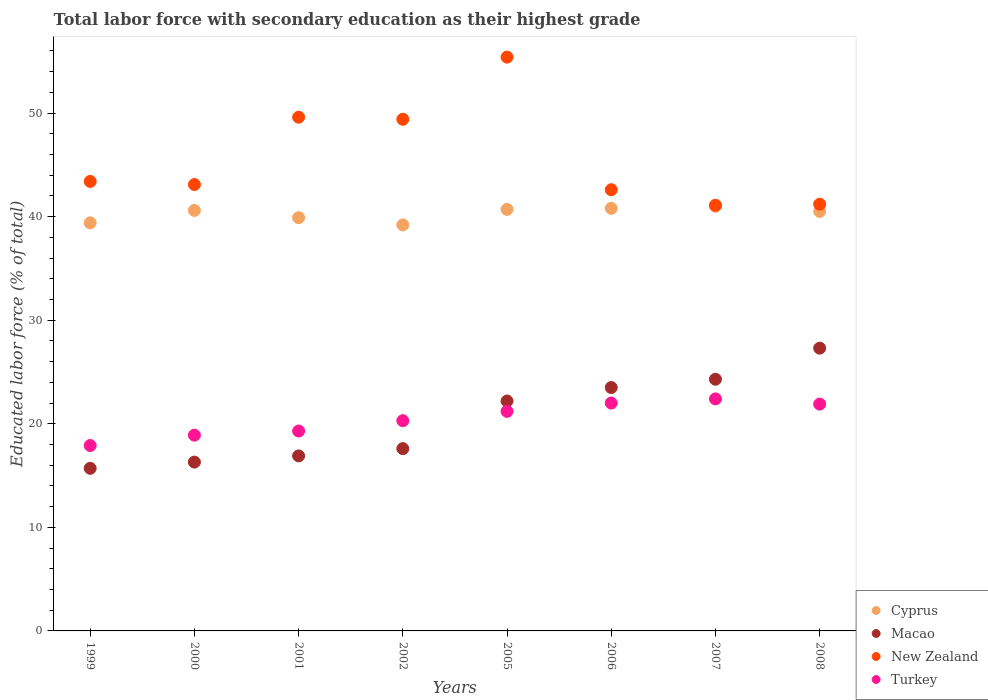How many different coloured dotlines are there?
Your response must be concise. 4. Is the number of dotlines equal to the number of legend labels?
Your answer should be compact. Yes. What is the percentage of total labor force with primary education in Macao in 2005?
Your answer should be very brief. 22.2. Across all years, what is the maximum percentage of total labor force with primary education in Cyprus?
Provide a short and direct response. 41. Across all years, what is the minimum percentage of total labor force with primary education in Macao?
Ensure brevity in your answer.  15.7. What is the total percentage of total labor force with primary education in Turkey in the graph?
Offer a terse response. 163.9. What is the difference between the percentage of total labor force with primary education in Macao in 2002 and that in 2006?
Offer a very short reply. -5.9. What is the difference between the percentage of total labor force with primary education in Turkey in 2006 and the percentage of total labor force with primary education in Cyprus in 1999?
Make the answer very short. -17.4. What is the average percentage of total labor force with primary education in Turkey per year?
Offer a very short reply. 20.49. In the year 2000, what is the difference between the percentage of total labor force with primary education in Macao and percentage of total labor force with primary education in New Zealand?
Offer a very short reply. -26.8. What is the ratio of the percentage of total labor force with primary education in Turkey in 1999 to that in 2002?
Ensure brevity in your answer.  0.88. Is the percentage of total labor force with primary education in Turkey in 2007 less than that in 2008?
Provide a succinct answer. No. What is the difference between the highest and the second highest percentage of total labor force with primary education in Cyprus?
Provide a short and direct response. 0.2. What is the difference between the highest and the lowest percentage of total labor force with primary education in New Zealand?
Provide a succinct answer. 14.3. Does the percentage of total labor force with primary education in Cyprus monotonically increase over the years?
Give a very brief answer. No. Is the percentage of total labor force with primary education in Macao strictly greater than the percentage of total labor force with primary education in Cyprus over the years?
Give a very brief answer. No. Is the percentage of total labor force with primary education in Cyprus strictly less than the percentage of total labor force with primary education in Turkey over the years?
Your answer should be very brief. No. How many dotlines are there?
Provide a short and direct response. 4. What is the difference between two consecutive major ticks on the Y-axis?
Provide a short and direct response. 10. Are the values on the major ticks of Y-axis written in scientific E-notation?
Your answer should be compact. No. Does the graph contain any zero values?
Offer a very short reply. No. Does the graph contain grids?
Keep it short and to the point. No. Where does the legend appear in the graph?
Your response must be concise. Bottom right. How many legend labels are there?
Your answer should be very brief. 4. What is the title of the graph?
Provide a short and direct response. Total labor force with secondary education as their highest grade. What is the label or title of the Y-axis?
Your answer should be very brief. Educated labor force (% of total). What is the Educated labor force (% of total) in Cyprus in 1999?
Give a very brief answer. 39.4. What is the Educated labor force (% of total) of Macao in 1999?
Provide a short and direct response. 15.7. What is the Educated labor force (% of total) of New Zealand in 1999?
Your response must be concise. 43.4. What is the Educated labor force (% of total) of Turkey in 1999?
Provide a succinct answer. 17.9. What is the Educated labor force (% of total) in Cyprus in 2000?
Provide a succinct answer. 40.6. What is the Educated labor force (% of total) of Macao in 2000?
Ensure brevity in your answer.  16.3. What is the Educated labor force (% of total) in New Zealand in 2000?
Provide a succinct answer. 43.1. What is the Educated labor force (% of total) of Turkey in 2000?
Your answer should be very brief. 18.9. What is the Educated labor force (% of total) of Cyprus in 2001?
Your answer should be very brief. 39.9. What is the Educated labor force (% of total) of Macao in 2001?
Your response must be concise. 16.9. What is the Educated labor force (% of total) of New Zealand in 2001?
Your response must be concise. 49.6. What is the Educated labor force (% of total) in Turkey in 2001?
Give a very brief answer. 19.3. What is the Educated labor force (% of total) in Cyprus in 2002?
Provide a succinct answer. 39.2. What is the Educated labor force (% of total) in Macao in 2002?
Offer a very short reply. 17.6. What is the Educated labor force (% of total) in New Zealand in 2002?
Make the answer very short. 49.4. What is the Educated labor force (% of total) in Turkey in 2002?
Provide a short and direct response. 20.3. What is the Educated labor force (% of total) in Cyprus in 2005?
Offer a very short reply. 40.7. What is the Educated labor force (% of total) of Macao in 2005?
Offer a very short reply. 22.2. What is the Educated labor force (% of total) of New Zealand in 2005?
Provide a short and direct response. 55.4. What is the Educated labor force (% of total) in Turkey in 2005?
Keep it short and to the point. 21.2. What is the Educated labor force (% of total) in Cyprus in 2006?
Make the answer very short. 40.8. What is the Educated labor force (% of total) in Macao in 2006?
Offer a terse response. 23.5. What is the Educated labor force (% of total) in New Zealand in 2006?
Offer a very short reply. 42.6. What is the Educated labor force (% of total) of Cyprus in 2007?
Keep it short and to the point. 41. What is the Educated labor force (% of total) in Macao in 2007?
Your answer should be compact. 24.3. What is the Educated labor force (% of total) of New Zealand in 2007?
Provide a succinct answer. 41.1. What is the Educated labor force (% of total) of Turkey in 2007?
Your answer should be very brief. 22.4. What is the Educated labor force (% of total) of Cyprus in 2008?
Give a very brief answer. 40.5. What is the Educated labor force (% of total) in Macao in 2008?
Offer a very short reply. 27.3. What is the Educated labor force (% of total) of New Zealand in 2008?
Give a very brief answer. 41.2. What is the Educated labor force (% of total) of Turkey in 2008?
Give a very brief answer. 21.9. Across all years, what is the maximum Educated labor force (% of total) of Macao?
Keep it short and to the point. 27.3. Across all years, what is the maximum Educated labor force (% of total) of New Zealand?
Give a very brief answer. 55.4. Across all years, what is the maximum Educated labor force (% of total) of Turkey?
Give a very brief answer. 22.4. Across all years, what is the minimum Educated labor force (% of total) in Cyprus?
Provide a succinct answer. 39.2. Across all years, what is the minimum Educated labor force (% of total) of Macao?
Make the answer very short. 15.7. Across all years, what is the minimum Educated labor force (% of total) in New Zealand?
Ensure brevity in your answer.  41.1. Across all years, what is the minimum Educated labor force (% of total) in Turkey?
Make the answer very short. 17.9. What is the total Educated labor force (% of total) in Cyprus in the graph?
Offer a very short reply. 322.1. What is the total Educated labor force (% of total) in Macao in the graph?
Your answer should be very brief. 163.8. What is the total Educated labor force (% of total) in New Zealand in the graph?
Ensure brevity in your answer.  365.8. What is the total Educated labor force (% of total) in Turkey in the graph?
Your answer should be very brief. 163.9. What is the difference between the Educated labor force (% of total) of Cyprus in 1999 and that in 2000?
Provide a short and direct response. -1.2. What is the difference between the Educated labor force (% of total) of Macao in 1999 and that in 2000?
Keep it short and to the point. -0.6. What is the difference between the Educated labor force (% of total) in Turkey in 1999 and that in 2000?
Keep it short and to the point. -1. What is the difference between the Educated labor force (% of total) of Cyprus in 1999 and that in 2001?
Give a very brief answer. -0.5. What is the difference between the Educated labor force (% of total) of Turkey in 1999 and that in 2001?
Give a very brief answer. -1.4. What is the difference between the Educated labor force (% of total) of Cyprus in 1999 and that in 2002?
Provide a short and direct response. 0.2. What is the difference between the Educated labor force (% of total) of Macao in 1999 and that in 2002?
Provide a succinct answer. -1.9. What is the difference between the Educated labor force (% of total) of New Zealand in 1999 and that in 2002?
Offer a terse response. -6. What is the difference between the Educated labor force (% of total) in Macao in 1999 and that in 2005?
Your answer should be very brief. -6.5. What is the difference between the Educated labor force (% of total) of New Zealand in 1999 and that in 2005?
Keep it short and to the point. -12. What is the difference between the Educated labor force (% of total) of Turkey in 1999 and that in 2005?
Offer a very short reply. -3.3. What is the difference between the Educated labor force (% of total) of Macao in 1999 and that in 2006?
Provide a short and direct response. -7.8. What is the difference between the Educated labor force (% of total) of Turkey in 1999 and that in 2006?
Provide a succinct answer. -4.1. What is the difference between the Educated labor force (% of total) in Macao in 1999 and that in 2007?
Your answer should be very brief. -8.6. What is the difference between the Educated labor force (% of total) of Cyprus in 1999 and that in 2008?
Make the answer very short. -1.1. What is the difference between the Educated labor force (% of total) of Macao in 1999 and that in 2008?
Provide a succinct answer. -11.6. What is the difference between the Educated labor force (% of total) in Turkey in 1999 and that in 2008?
Make the answer very short. -4. What is the difference between the Educated labor force (% of total) in Cyprus in 2000 and that in 2001?
Ensure brevity in your answer.  0.7. What is the difference between the Educated labor force (% of total) in Macao in 2000 and that in 2001?
Offer a very short reply. -0.6. What is the difference between the Educated labor force (% of total) in New Zealand in 2000 and that in 2001?
Provide a short and direct response. -6.5. What is the difference between the Educated labor force (% of total) in Cyprus in 2000 and that in 2002?
Offer a very short reply. 1.4. What is the difference between the Educated labor force (% of total) of Turkey in 2000 and that in 2002?
Ensure brevity in your answer.  -1.4. What is the difference between the Educated labor force (% of total) in Cyprus in 2000 and that in 2005?
Ensure brevity in your answer.  -0.1. What is the difference between the Educated labor force (% of total) of Macao in 2000 and that in 2006?
Your answer should be compact. -7.2. What is the difference between the Educated labor force (% of total) of Cyprus in 2000 and that in 2007?
Keep it short and to the point. -0.4. What is the difference between the Educated labor force (% of total) of New Zealand in 2000 and that in 2007?
Your response must be concise. 2. What is the difference between the Educated labor force (% of total) of Cyprus in 2000 and that in 2008?
Ensure brevity in your answer.  0.1. What is the difference between the Educated labor force (% of total) in New Zealand in 2000 and that in 2008?
Your answer should be compact. 1.9. What is the difference between the Educated labor force (% of total) in Macao in 2001 and that in 2002?
Offer a terse response. -0.7. What is the difference between the Educated labor force (% of total) in New Zealand in 2001 and that in 2002?
Your answer should be compact. 0.2. What is the difference between the Educated labor force (% of total) in Turkey in 2001 and that in 2002?
Your answer should be compact. -1. What is the difference between the Educated labor force (% of total) of Macao in 2001 and that in 2005?
Make the answer very short. -5.3. What is the difference between the Educated labor force (% of total) of New Zealand in 2001 and that in 2005?
Your answer should be compact. -5.8. What is the difference between the Educated labor force (% of total) in Macao in 2001 and that in 2007?
Keep it short and to the point. -7.4. What is the difference between the Educated labor force (% of total) in Cyprus in 2001 and that in 2008?
Keep it short and to the point. -0.6. What is the difference between the Educated labor force (% of total) in New Zealand in 2001 and that in 2008?
Your response must be concise. 8.4. What is the difference between the Educated labor force (% of total) of Turkey in 2001 and that in 2008?
Your answer should be compact. -2.6. What is the difference between the Educated labor force (% of total) of Cyprus in 2002 and that in 2005?
Provide a succinct answer. -1.5. What is the difference between the Educated labor force (% of total) of Macao in 2002 and that in 2005?
Offer a very short reply. -4.6. What is the difference between the Educated labor force (% of total) of Turkey in 2002 and that in 2005?
Provide a short and direct response. -0.9. What is the difference between the Educated labor force (% of total) in New Zealand in 2002 and that in 2006?
Give a very brief answer. 6.8. What is the difference between the Educated labor force (% of total) in Turkey in 2002 and that in 2006?
Give a very brief answer. -1.7. What is the difference between the Educated labor force (% of total) in Cyprus in 2002 and that in 2007?
Offer a terse response. -1.8. What is the difference between the Educated labor force (% of total) of New Zealand in 2002 and that in 2007?
Make the answer very short. 8.3. What is the difference between the Educated labor force (% of total) of Turkey in 2002 and that in 2007?
Keep it short and to the point. -2.1. What is the difference between the Educated labor force (% of total) in New Zealand in 2002 and that in 2008?
Keep it short and to the point. 8.2. What is the difference between the Educated labor force (% of total) in Cyprus in 2005 and that in 2006?
Give a very brief answer. -0.1. What is the difference between the Educated labor force (% of total) of Macao in 2005 and that in 2007?
Keep it short and to the point. -2.1. What is the difference between the Educated labor force (% of total) in New Zealand in 2005 and that in 2007?
Provide a succinct answer. 14.3. What is the difference between the Educated labor force (% of total) of Cyprus in 2005 and that in 2008?
Your answer should be compact. 0.2. What is the difference between the Educated labor force (% of total) of Macao in 2005 and that in 2008?
Keep it short and to the point. -5.1. What is the difference between the Educated labor force (% of total) in Cyprus in 2006 and that in 2007?
Your answer should be very brief. -0.2. What is the difference between the Educated labor force (% of total) of Turkey in 2006 and that in 2007?
Make the answer very short. -0.4. What is the difference between the Educated labor force (% of total) in Cyprus in 2006 and that in 2008?
Keep it short and to the point. 0.3. What is the difference between the Educated labor force (% of total) of Macao in 2006 and that in 2008?
Ensure brevity in your answer.  -3.8. What is the difference between the Educated labor force (% of total) in New Zealand in 2006 and that in 2008?
Offer a terse response. 1.4. What is the difference between the Educated labor force (% of total) of Cyprus in 2007 and that in 2008?
Offer a terse response. 0.5. What is the difference between the Educated labor force (% of total) of Cyprus in 1999 and the Educated labor force (% of total) of Macao in 2000?
Offer a very short reply. 23.1. What is the difference between the Educated labor force (% of total) in Cyprus in 1999 and the Educated labor force (% of total) in Turkey in 2000?
Keep it short and to the point. 20.5. What is the difference between the Educated labor force (% of total) of Macao in 1999 and the Educated labor force (% of total) of New Zealand in 2000?
Offer a terse response. -27.4. What is the difference between the Educated labor force (% of total) in Cyprus in 1999 and the Educated labor force (% of total) in Macao in 2001?
Offer a terse response. 22.5. What is the difference between the Educated labor force (% of total) in Cyprus in 1999 and the Educated labor force (% of total) in Turkey in 2001?
Your answer should be very brief. 20.1. What is the difference between the Educated labor force (% of total) of Macao in 1999 and the Educated labor force (% of total) of New Zealand in 2001?
Provide a succinct answer. -33.9. What is the difference between the Educated labor force (% of total) of New Zealand in 1999 and the Educated labor force (% of total) of Turkey in 2001?
Your response must be concise. 24.1. What is the difference between the Educated labor force (% of total) in Cyprus in 1999 and the Educated labor force (% of total) in Macao in 2002?
Make the answer very short. 21.8. What is the difference between the Educated labor force (% of total) of Macao in 1999 and the Educated labor force (% of total) of New Zealand in 2002?
Offer a terse response. -33.7. What is the difference between the Educated labor force (% of total) of Macao in 1999 and the Educated labor force (% of total) of Turkey in 2002?
Ensure brevity in your answer.  -4.6. What is the difference between the Educated labor force (% of total) of New Zealand in 1999 and the Educated labor force (% of total) of Turkey in 2002?
Keep it short and to the point. 23.1. What is the difference between the Educated labor force (% of total) in Cyprus in 1999 and the Educated labor force (% of total) in Macao in 2005?
Your answer should be compact. 17.2. What is the difference between the Educated labor force (% of total) in Cyprus in 1999 and the Educated labor force (% of total) in New Zealand in 2005?
Your answer should be very brief. -16. What is the difference between the Educated labor force (% of total) of Macao in 1999 and the Educated labor force (% of total) of New Zealand in 2005?
Your response must be concise. -39.7. What is the difference between the Educated labor force (% of total) of Cyprus in 1999 and the Educated labor force (% of total) of Macao in 2006?
Make the answer very short. 15.9. What is the difference between the Educated labor force (% of total) of Cyprus in 1999 and the Educated labor force (% of total) of New Zealand in 2006?
Your answer should be compact. -3.2. What is the difference between the Educated labor force (% of total) in Cyprus in 1999 and the Educated labor force (% of total) in Turkey in 2006?
Make the answer very short. 17.4. What is the difference between the Educated labor force (% of total) of Macao in 1999 and the Educated labor force (% of total) of New Zealand in 2006?
Offer a terse response. -26.9. What is the difference between the Educated labor force (% of total) of New Zealand in 1999 and the Educated labor force (% of total) of Turkey in 2006?
Offer a very short reply. 21.4. What is the difference between the Educated labor force (% of total) of Cyprus in 1999 and the Educated labor force (% of total) of Macao in 2007?
Give a very brief answer. 15.1. What is the difference between the Educated labor force (% of total) in Cyprus in 1999 and the Educated labor force (% of total) in Turkey in 2007?
Your response must be concise. 17. What is the difference between the Educated labor force (% of total) in Macao in 1999 and the Educated labor force (% of total) in New Zealand in 2007?
Your response must be concise. -25.4. What is the difference between the Educated labor force (% of total) in New Zealand in 1999 and the Educated labor force (% of total) in Turkey in 2007?
Your answer should be very brief. 21. What is the difference between the Educated labor force (% of total) in Cyprus in 1999 and the Educated labor force (% of total) in Macao in 2008?
Ensure brevity in your answer.  12.1. What is the difference between the Educated labor force (% of total) in Cyprus in 1999 and the Educated labor force (% of total) in Turkey in 2008?
Provide a succinct answer. 17.5. What is the difference between the Educated labor force (% of total) of Macao in 1999 and the Educated labor force (% of total) of New Zealand in 2008?
Your answer should be very brief. -25.5. What is the difference between the Educated labor force (% of total) in New Zealand in 1999 and the Educated labor force (% of total) in Turkey in 2008?
Your answer should be very brief. 21.5. What is the difference between the Educated labor force (% of total) in Cyprus in 2000 and the Educated labor force (% of total) in Macao in 2001?
Keep it short and to the point. 23.7. What is the difference between the Educated labor force (% of total) of Cyprus in 2000 and the Educated labor force (% of total) of New Zealand in 2001?
Your answer should be very brief. -9. What is the difference between the Educated labor force (% of total) in Cyprus in 2000 and the Educated labor force (% of total) in Turkey in 2001?
Offer a very short reply. 21.3. What is the difference between the Educated labor force (% of total) in Macao in 2000 and the Educated labor force (% of total) in New Zealand in 2001?
Make the answer very short. -33.3. What is the difference between the Educated labor force (% of total) of Macao in 2000 and the Educated labor force (% of total) of Turkey in 2001?
Ensure brevity in your answer.  -3. What is the difference between the Educated labor force (% of total) in New Zealand in 2000 and the Educated labor force (% of total) in Turkey in 2001?
Your response must be concise. 23.8. What is the difference between the Educated labor force (% of total) in Cyprus in 2000 and the Educated labor force (% of total) in Turkey in 2002?
Give a very brief answer. 20.3. What is the difference between the Educated labor force (% of total) of Macao in 2000 and the Educated labor force (% of total) of New Zealand in 2002?
Keep it short and to the point. -33.1. What is the difference between the Educated labor force (% of total) of New Zealand in 2000 and the Educated labor force (% of total) of Turkey in 2002?
Your response must be concise. 22.8. What is the difference between the Educated labor force (% of total) of Cyprus in 2000 and the Educated labor force (% of total) of Macao in 2005?
Your response must be concise. 18.4. What is the difference between the Educated labor force (% of total) of Cyprus in 2000 and the Educated labor force (% of total) of New Zealand in 2005?
Your answer should be compact. -14.8. What is the difference between the Educated labor force (% of total) in Cyprus in 2000 and the Educated labor force (% of total) in Turkey in 2005?
Provide a succinct answer. 19.4. What is the difference between the Educated labor force (% of total) of Macao in 2000 and the Educated labor force (% of total) of New Zealand in 2005?
Provide a short and direct response. -39.1. What is the difference between the Educated labor force (% of total) of New Zealand in 2000 and the Educated labor force (% of total) of Turkey in 2005?
Provide a short and direct response. 21.9. What is the difference between the Educated labor force (% of total) in Cyprus in 2000 and the Educated labor force (% of total) in New Zealand in 2006?
Keep it short and to the point. -2. What is the difference between the Educated labor force (% of total) of Cyprus in 2000 and the Educated labor force (% of total) of Turkey in 2006?
Keep it short and to the point. 18.6. What is the difference between the Educated labor force (% of total) in Macao in 2000 and the Educated labor force (% of total) in New Zealand in 2006?
Offer a very short reply. -26.3. What is the difference between the Educated labor force (% of total) in New Zealand in 2000 and the Educated labor force (% of total) in Turkey in 2006?
Provide a succinct answer. 21.1. What is the difference between the Educated labor force (% of total) of Cyprus in 2000 and the Educated labor force (% of total) of New Zealand in 2007?
Ensure brevity in your answer.  -0.5. What is the difference between the Educated labor force (% of total) of Cyprus in 2000 and the Educated labor force (% of total) of Turkey in 2007?
Ensure brevity in your answer.  18.2. What is the difference between the Educated labor force (% of total) in Macao in 2000 and the Educated labor force (% of total) in New Zealand in 2007?
Your answer should be very brief. -24.8. What is the difference between the Educated labor force (% of total) in Macao in 2000 and the Educated labor force (% of total) in Turkey in 2007?
Provide a short and direct response. -6.1. What is the difference between the Educated labor force (% of total) of New Zealand in 2000 and the Educated labor force (% of total) of Turkey in 2007?
Your answer should be compact. 20.7. What is the difference between the Educated labor force (% of total) of Cyprus in 2000 and the Educated labor force (% of total) of New Zealand in 2008?
Offer a terse response. -0.6. What is the difference between the Educated labor force (% of total) of Cyprus in 2000 and the Educated labor force (% of total) of Turkey in 2008?
Offer a very short reply. 18.7. What is the difference between the Educated labor force (% of total) in Macao in 2000 and the Educated labor force (% of total) in New Zealand in 2008?
Your answer should be compact. -24.9. What is the difference between the Educated labor force (% of total) of Macao in 2000 and the Educated labor force (% of total) of Turkey in 2008?
Offer a terse response. -5.6. What is the difference between the Educated labor force (% of total) of New Zealand in 2000 and the Educated labor force (% of total) of Turkey in 2008?
Give a very brief answer. 21.2. What is the difference between the Educated labor force (% of total) of Cyprus in 2001 and the Educated labor force (% of total) of Macao in 2002?
Provide a succinct answer. 22.3. What is the difference between the Educated labor force (% of total) of Cyprus in 2001 and the Educated labor force (% of total) of New Zealand in 2002?
Ensure brevity in your answer.  -9.5. What is the difference between the Educated labor force (% of total) in Cyprus in 2001 and the Educated labor force (% of total) in Turkey in 2002?
Offer a very short reply. 19.6. What is the difference between the Educated labor force (% of total) of Macao in 2001 and the Educated labor force (% of total) of New Zealand in 2002?
Your response must be concise. -32.5. What is the difference between the Educated labor force (% of total) of New Zealand in 2001 and the Educated labor force (% of total) of Turkey in 2002?
Keep it short and to the point. 29.3. What is the difference between the Educated labor force (% of total) of Cyprus in 2001 and the Educated labor force (% of total) of Macao in 2005?
Offer a very short reply. 17.7. What is the difference between the Educated labor force (% of total) in Cyprus in 2001 and the Educated labor force (% of total) in New Zealand in 2005?
Your answer should be compact. -15.5. What is the difference between the Educated labor force (% of total) of Macao in 2001 and the Educated labor force (% of total) of New Zealand in 2005?
Your answer should be very brief. -38.5. What is the difference between the Educated labor force (% of total) in Macao in 2001 and the Educated labor force (% of total) in Turkey in 2005?
Provide a short and direct response. -4.3. What is the difference between the Educated labor force (% of total) in New Zealand in 2001 and the Educated labor force (% of total) in Turkey in 2005?
Ensure brevity in your answer.  28.4. What is the difference between the Educated labor force (% of total) of Cyprus in 2001 and the Educated labor force (% of total) of Turkey in 2006?
Offer a terse response. 17.9. What is the difference between the Educated labor force (% of total) of Macao in 2001 and the Educated labor force (% of total) of New Zealand in 2006?
Your answer should be very brief. -25.7. What is the difference between the Educated labor force (% of total) in Macao in 2001 and the Educated labor force (% of total) in Turkey in 2006?
Make the answer very short. -5.1. What is the difference between the Educated labor force (% of total) of New Zealand in 2001 and the Educated labor force (% of total) of Turkey in 2006?
Your answer should be very brief. 27.6. What is the difference between the Educated labor force (% of total) in Cyprus in 2001 and the Educated labor force (% of total) in Macao in 2007?
Give a very brief answer. 15.6. What is the difference between the Educated labor force (% of total) in Cyprus in 2001 and the Educated labor force (% of total) in Turkey in 2007?
Give a very brief answer. 17.5. What is the difference between the Educated labor force (% of total) of Macao in 2001 and the Educated labor force (% of total) of New Zealand in 2007?
Your answer should be compact. -24.2. What is the difference between the Educated labor force (% of total) of New Zealand in 2001 and the Educated labor force (% of total) of Turkey in 2007?
Keep it short and to the point. 27.2. What is the difference between the Educated labor force (% of total) of Cyprus in 2001 and the Educated labor force (% of total) of New Zealand in 2008?
Give a very brief answer. -1.3. What is the difference between the Educated labor force (% of total) of Cyprus in 2001 and the Educated labor force (% of total) of Turkey in 2008?
Provide a succinct answer. 18. What is the difference between the Educated labor force (% of total) of Macao in 2001 and the Educated labor force (% of total) of New Zealand in 2008?
Offer a very short reply. -24.3. What is the difference between the Educated labor force (% of total) of New Zealand in 2001 and the Educated labor force (% of total) of Turkey in 2008?
Offer a very short reply. 27.7. What is the difference between the Educated labor force (% of total) of Cyprus in 2002 and the Educated labor force (% of total) of New Zealand in 2005?
Give a very brief answer. -16.2. What is the difference between the Educated labor force (% of total) of Macao in 2002 and the Educated labor force (% of total) of New Zealand in 2005?
Ensure brevity in your answer.  -37.8. What is the difference between the Educated labor force (% of total) of New Zealand in 2002 and the Educated labor force (% of total) of Turkey in 2005?
Provide a short and direct response. 28.2. What is the difference between the Educated labor force (% of total) in Cyprus in 2002 and the Educated labor force (% of total) in Macao in 2006?
Offer a terse response. 15.7. What is the difference between the Educated labor force (% of total) of Cyprus in 2002 and the Educated labor force (% of total) of New Zealand in 2006?
Keep it short and to the point. -3.4. What is the difference between the Educated labor force (% of total) in Macao in 2002 and the Educated labor force (% of total) in Turkey in 2006?
Your answer should be very brief. -4.4. What is the difference between the Educated labor force (% of total) in New Zealand in 2002 and the Educated labor force (% of total) in Turkey in 2006?
Make the answer very short. 27.4. What is the difference between the Educated labor force (% of total) in Macao in 2002 and the Educated labor force (% of total) in New Zealand in 2007?
Provide a short and direct response. -23.5. What is the difference between the Educated labor force (% of total) in Cyprus in 2002 and the Educated labor force (% of total) in New Zealand in 2008?
Your answer should be very brief. -2. What is the difference between the Educated labor force (% of total) in Cyprus in 2002 and the Educated labor force (% of total) in Turkey in 2008?
Provide a short and direct response. 17.3. What is the difference between the Educated labor force (% of total) in Macao in 2002 and the Educated labor force (% of total) in New Zealand in 2008?
Offer a terse response. -23.6. What is the difference between the Educated labor force (% of total) in Macao in 2002 and the Educated labor force (% of total) in Turkey in 2008?
Provide a succinct answer. -4.3. What is the difference between the Educated labor force (% of total) in Cyprus in 2005 and the Educated labor force (% of total) in New Zealand in 2006?
Provide a short and direct response. -1.9. What is the difference between the Educated labor force (% of total) of Macao in 2005 and the Educated labor force (% of total) of New Zealand in 2006?
Your answer should be compact. -20.4. What is the difference between the Educated labor force (% of total) in Macao in 2005 and the Educated labor force (% of total) in Turkey in 2006?
Your answer should be compact. 0.2. What is the difference between the Educated labor force (% of total) of New Zealand in 2005 and the Educated labor force (% of total) of Turkey in 2006?
Ensure brevity in your answer.  33.4. What is the difference between the Educated labor force (% of total) of Cyprus in 2005 and the Educated labor force (% of total) of Macao in 2007?
Give a very brief answer. 16.4. What is the difference between the Educated labor force (% of total) of Macao in 2005 and the Educated labor force (% of total) of New Zealand in 2007?
Make the answer very short. -18.9. What is the difference between the Educated labor force (% of total) of Macao in 2005 and the Educated labor force (% of total) of Turkey in 2007?
Provide a succinct answer. -0.2. What is the difference between the Educated labor force (% of total) in Cyprus in 2005 and the Educated labor force (% of total) in Macao in 2008?
Offer a terse response. 13.4. What is the difference between the Educated labor force (% of total) in Cyprus in 2005 and the Educated labor force (% of total) in New Zealand in 2008?
Offer a terse response. -0.5. What is the difference between the Educated labor force (% of total) of Macao in 2005 and the Educated labor force (% of total) of New Zealand in 2008?
Offer a terse response. -19. What is the difference between the Educated labor force (% of total) in Macao in 2005 and the Educated labor force (% of total) in Turkey in 2008?
Offer a very short reply. 0.3. What is the difference between the Educated labor force (% of total) of New Zealand in 2005 and the Educated labor force (% of total) of Turkey in 2008?
Your response must be concise. 33.5. What is the difference between the Educated labor force (% of total) of Macao in 2006 and the Educated labor force (% of total) of New Zealand in 2007?
Offer a terse response. -17.6. What is the difference between the Educated labor force (% of total) of New Zealand in 2006 and the Educated labor force (% of total) of Turkey in 2007?
Give a very brief answer. 20.2. What is the difference between the Educated labor force (% of total) in Cyprus in 2006 and the Educated labor force (% of total) in Macao in 2008?
Offer a very short reply. 13.5. What is the difference between the Educated labor force (% of total) of Cyprus in 2006 and the Educated labor force (% of total) of New Zealand in 2008?
Your response must be concise. -0.4. What is the difference between the Educated labor force (% of total) in Cyprus in 2006 and the Educated labor force (% of total) in Turkey in 2008?
Provide a succinct answer. 18.9. What is the difference between the Educated labor force (% of total) in Macao in 2006 and the Educated labor force (% of total) in New Zealand in 2008?
Make the answer very short. -17.7. What is the difference between the Educated labor force (% of total) in Macao in 2006 and the Educated labor force (% of total) in Turkey in 2008?
Offer a very short reply. 1.6. What is the difference between the Educated labor force (% of total) of New Zealand in 2006 and the Educated labor force (% of total) of Turkey in 2008?
Your response must be concise. 20.7. What is the difference between the Educated labor force (% of total) of Cyprus in 2007 and the Educated labor force (% of total) of Macao in 2008?
Offer a very short reply. 13.7. What is the difference between the Educated labor force (% of total) in Cyprus in 2007 and the Educated labor force (% of total) in New Zealand in 2008?
Your response must be concise. -0.2. What is the difference between the Educated labor force (% of total) in Cyprus in 2007 and the Educated labor force (% of total) in Turkey in 2008?
Keep it short and to the point. 19.1. What is the difference between the Educated labor force (% of total) in Macao in 2007 and the Educated labor force (% of total) in New Zealand in 2008?
Your answer should be very brief. -16.9. What is the difference between the Educated labor force (% of total) of Macao in 2007 and the Educated labor force (% of total) of Turkey in 2008?
Provide a short and direct response. 2.4. What is the difference between the Educated labor force (% of total) of New Zealand in 2007 and the Educated labor force (% of total) of Turkey in 2008?
Offer a very short reply. 19.2. What is the average Educated labor force (% of total) of Cyprus per year?
Your answer should be very brief. 40.26. What is the average Educated labor force (% of total) of Macao per year?
Make the answer very short. 20.48. What is the average Educated labor force (% of total) in New Zealand per year?
Offer a very short reply. 45.73. What is the average Educated labor force (% of total) in Turkey per year?
Make the answer very short. 20.49. In the year 1999, what is the difference between the Educated labor force (% of total) of Cyprus and Educated labor force (% of total) of Macao?
Keep it short and to the point. 23.7. In the year 1999, what is the difference between the Educated labor force (% of total) in Cyprus and Educated labor force (% of total) in Turkey?
Keep it short and to the point. 21.5. In the year 1999, what is the difference between the Educated labor force (% of total) in Macao and Educated labor force (% of total) in New Zealand?
Offer a terse response. -27.7. In the year 1999, what is the difference between the Educated labor force (% of total) in New Zealand and Educated labor force (% of total) in Turkey?
Provide a succinct answer. 25.5. In the year 2000, what is the difference between the Educated labor force (% of total) of Cyprus and Educated labor force (% of total) of Macao?
Your response must be concise. 24.3. In the year 2000, what is the difference between the Educated labor force (% of total) of Cyprus and Educated labor force (% of total) of Turkey?
Give a very brief answer. 21.7. In the year 2000, what is the difference between the Educated labor force (% of total) in Macao and Educated labor force (% of total) in New Zealand?
Make the answer very short. -26.8. In the year 2000, what is the difference between the Educated labor force (% of total) of New Zealand and Educated labor force (% of total) of Turkey?
Keep it short and to the point. 24.2. In the year 2001, what is the difference between the Educated labor force (% of total) of Cyprus and Educated labor force (% of total) of Macao?
Keep it short and to the point. 23. In the year 2001, what is the difference between the Educated labor force (% of total) of Cyprus and Educated labor force (% of total) of Turkey?
Offer a very short reply. 20.6. In the year 2001, what is the difference between the Educated labor force (% of total) of Macao and Educated labor force (% of total) of New Zealand?
Make the answer very short. -32.7. In the year 2001, what is the difference between the Educated labor force (% of total) in New Zealand and Educated labor force (% of total) in Turkey?
Offer a terse response. 30.3. In the year 2002, what is the difference between the Educated labor force (% of total) in Cyprus and Educated labor force (% of total) in Macao?
Your answer should be compact. 21.6. In the year 2002, what is the difference between the Educated labor force (% of total) of Cyprus and Educated labor force (% of total) of New Zealand?
Your answer should be very brief. -10.2. In the year 2002, what is the difference between the Educated labor force (% of total) in Macao and Educated labor force (% of total) in New Zealand?
Give a very brief answer. -31.8. In the year 2002, what is the difference between the Educated labor force (% of total) of New Zealand and Educated labor force (% of total) of Turkey?
Your response must be concise. 29.1. In the year 2005, what is the difference between the Educated labor force (% of total) in Cyprus and Educated labor force (% of total) in Macao?
Offer a very short reply. 18.5. In the year 2005, what is the difference between the Educated labor force (% of total) in Cyprus and Educated labor force (% of total) in New Zealand?
Your answer should be compact. -14.7. In the year 2005, what is the difference between the Educated labor force (% of total) in Macao and Educated labor force (% of total) in New Zealand?
Make the answer very short. -33.2. In the year 2005, what is the difference between the Educated labor force (% of total) of New Zealand and Educated labor force (% of total) of Turkey?
Provide a short and direct response. 34.2. In the year 2006, what is the difference between the Educated labor force (% of total) in Cyprus and Educated labor force (% of total) in Macao?
Provide a short and direct response. 17.3. In the year 2006, what is the difference between the Educated labor force (% of total) of Cyprus and Educated labor force (% of total) of New Zealand?
Offer a terse response. -1.8. In the year 2006, what is the difference between the Educated labor force (% of total) of Cyprus and Educated labor force (% of total) of Turkey?
Your response must be concise. 18.8. In the year 2006, what is the difference between the Educated labor force (% of total) in Macao and Educated labor force (% of total) in New Zealand?
Keep it short and to the point. -19.1. In the year 2006, what is the difference between the Educated labor force (% of total) in Macao and Educated labor force (% of total) in Turkey?
Ensure brevity in your answer.  1.5. In the year 2006, what is the difference between the Educated labor force (% of total) of New Zealand and Educated labor force (% of total) of Turkey?
Make the answer very short. 20.6. In the year 2007, what is the difference between the Educated labor force (% of total) in Cyprus and Educated labor force (% of total) in Macao?
Offer a very short reply. 16.7. In the year 2007, what is the difference between the Educated labor force (% of total) of Cyprus and Educated labor force (% of total) of New Zealand?
Provide a short and direct response. -0.1. In the year 2007, what is the difference between the Educated labor force (% of total) in Cyprus and Educated labor force (% of total) in Turkey?
Make the answer very short. 18.6. In the year 2007, what is the difference between the Educated labor force (% of total) in Macao and Educated labor force (% of total) in New Zealand?
Offer a terse response. -16.8. In the year 2007, what is the difference between the Educated labor force (% of total) of New Zealand and Educated labor force (% of total) of Turkey?
Give a very brief answer. 18.7. In the year 2008, what is the difference between the Educated labor force (% of total) in Cyprus and Educated labor force (% of total) in Macao?
Your answer should be very brief. 13.2. In the year 2008, what is the difference between the Educated labor force (% of total) of Cyprus and Educated labor force (% of total) of Turkey?
Make the answer very short. 18.6. In the year 2008, what is the difference between the Educated labor force (% of total) in New Zealand and Educated labor force (% of total) in Turkey?
Ensure brevity in your answer.  19.3. What is the ratio of the Educated labor force (% of total) of Cyprus in 1999 to that in 2000?
Your response must be concise. 0.97. What is the ratio of the Educated labor force (% of total) in Macao in 1999 to that in 2000?
Give a very brief answer. 0.96. What is the ratio of the Educated labor force (% of total) in New Zealand in 1999 to that in 2000?
Your answer should be compact. 1.01. What is the ratio of the Educated labor force (% of total) of Turkey in 1999 to that in 2000?
Your answer should be compact. 0.95. What is the ratio of the Educated labor force (% of total) in Cyprus in 1999 to that in 2001?
Offer a very short reply. 0.99. What is the ratio of the Educated labor force (% of total) in Macao in 1999 to that in 2001?
Provide a short and direct response. 0.93. What is the ratio of the Educated labor force (% of total) in New Zealand in 1999 to that in 2001?
Make the answer very short. 0.88. What is the ratio of the Educated labor force (% of total) in Turkey in 1999 to that in 2001?
Provide a succinct answer. 0.93. What is the ratio of the Educated labor force (% of total) in Cyprus in 1999 to that in 2002?
Provide a short and direct response. 1.01. What is the ratio of the Educated labor force (% of total) of Macao in 1999 to that in 2002?
Offer a very short reply. 0.89. What is the ratio of the Educated labor force (% of total) in New Zealand in 1999 to that in 2002?
Make the answer very short. 0.88. What is the ratio of the Educated labor force (% of total) of Turkey in 1999 to that in 2002?
Ensure brevity in your answer.  0.88. What is the ratio of the Educated labor force (% of total) of Cyprus in 1999 to that in 2005?
Provide a succinct answer. 0.97. What is the ratio of the Educated labor force (% of total) in Macao in 1999 to that in 2005?
Give a very brief answer. 0.71. What is the ratio of the Educated labor force (% of total) in New Zealand in 1999 to that in 2005?
Ensure brevity in your answer.  0.78. What is the ratio of the Educated labor force (% of total) of Turkey in 1999 to that in 2005?
Make the answer very short. 0.84. What is the ratio of the Educated labor force (% of total) of Cyprus in 1999 to that in 2006?
Ensure brevity in your answer.  0.97. What is the ratio of the Educated labor force (% of total) in Macao in 1999 to that in 2006?
Ensure brevity in your answer.  0.67. What is the ratio of the Educated labor force (% of total) of New Zealand in 1999 to that in 2006?
Your answer should be very brief. 1.02. What is the ratio of the Educated labor force (% of total) in Turkey in 1999 to that in 2006?
Offer a terse response. 0.81. What is the ratio of the Educated labor force (% of total) in Macao in 1999 to that in 2007?
Keep it short and to the point. 0.65. What is the ratio of the Educated labor force (% of total) in New Zealand in 1999 to that in 2007?
Ensure brevity in your answer.  1.06. What is the ratio of the Educated labor force (% of total) of Turkey in 1999 to that in 2007?
Ensure brevity in your answer.  0.8. What is the ratio of the Educated labor force (% of total) in Cyprus in 1999 to that in 2008?
Keep it short and to the point. 0.97. What is the ratio of the Educated labor force (% of total) of Macao in 1999 to that in 2008?
Your answer should be compact. 0.58. What is the ratio of the Educated labor force (% of total) in New Zealand in 1999 to that in 2008?
Provide a succinct answer. 1.05. What is the ratio of the Educated labor force (% of total) in Turkey in 1999 to that in 2008?
Your answer should be compact. 0.82. What is the ratio of the Educated labor force (% of total) of Cyprus in 2000 to that in 2001?
Give a very brief answer. 1.02. What is the ratio of the Educated labor force (% of total) in Macao in 2000 to that in 2001?
Offer a terse response. 0.96. What is the ratio of the Educated labor force (% of total) in New Zealand in 2000 to that in 2001?
Provide a succinct answer. 0.87. What is the ratio of the Educated labor force (% of total) in Turkey in 2000 to that in 2001?
Offer a very short reply. 0.98. What is the ratio of the Educated labor force (% of total) in Cyprus in 2000 to that in 2002?
Provide a short and direct response. 1.04. What is the ratio of the Educated labor force (% of total) in Macao in 2000 to that in 2002?
Your answer should be compact. 0.93. What is the ratio of the Educated labor force (% of total) of New Zealand in 2000 to that in 2002?
Provide a succinct answer. 0.87. What is the ratio of the Educated labor force (% of total) in Turkey in 2000 to that in 2002?
Your response must be concise. 0.93. What is the ratio of the Educated labor force (% of total) of Cyprus in 2000 to that in 2005?
Your answer should be very brief. 1. What is the ratio of the Educated labor force (% of total) of Macao in 2000 to that in 2005?
Your answer should be very brief. 0.73. What is the ratio of the Educated labor force (% of total) of New Zealand in 2000 to that in 2005?
Your answer should be compact. 0.78. What is the ratio of the Educated labor force (% of total) of Turkey in 2000 to that in 2005?
Offer a terse response. 0.89. What is the ratio of the Educated labor force (% of total) in Cyprus in 2000 to that in 2006?
Ensure brevity in your answer.  1. What is the ratio of the Educated labor force (% of total) of Macao in 2000 to that in 2006?
Make the answer very short. 0.69. What is the ratio of the Educated labor force (% of total) in New Zealand in 2000 to that in 2006?
Offer a terse response. 1.01. What is the ratio of the Educated labor force (% of total) in Turkey in 2000 to that in 2006?
Offer a terse response. 0.86. What is the ratio of the Educated labor force (% of total) in Cyprus in 2000 to that in 2007?
Provide a succinct answer. 0.99. What is the ratio of the Educated labor force (% of total) in Macao in 2000 to that in 2007?
Provide a short and direct response. 0.67. What is the ratio of the Educated labor force (% of total) of New Zealand in 2000 to that in 2007?
Offer a very short reply. 1.05. What is the ratio of the Educated labor force (% of total) of Turkey in 2000 to that in 2007?
Make the answer very short. 0.84. What is the ratio of the Educated labor force (% of total) in Cyprus in 2000 to that in 2008?
Keep it short and to the point. 1. What is the ratio of the Educated labor force (% of total) in Macao in 2000 to that in 2008?
Provide a succinct answer. 0.6. What is the ratio of the Educated labor force (% of total) of New Zealand in 2000 to that in 2008?
Make the answer very short. 1.05. What is the ratio of the Educated labor force (% of total) of Turkey in 2000 to that in 2008?
Your response must be concise. 0.86. What is the ratio of the Educated labor force (% of total) in Cyprus in 2001 to that in 2002?
Ensure brevity in your answer.  1.02. What is the ratio of the Educated labor force (% of total) of Macao in 2001 to that in 2002?
Your answer should be very brief. 0.96. What is the ratio of the Educated labor force (% of total) of New Zealand in 2001 to that in 2002?
Your answer should be compact. 1. What is the ratio of the Educated labor force (% of total) in Turkey in 2001 to that in 2002?
Your answer should be compact. 0.95. What is the ratio of the Educated labor force (% of total) of Cyprus in 2001 to that in 2005?
Give a very brief answer. 0.98. What is the ratio of the Educated labor force (% of total) in Macao in 2001 to that in 2005?
Ensure brevity in your answer.  0.76. What is the ratio of the Educated labor force (% of total) in New Zealand in 2001 to that in 2005?
Your response must be concise. 0.9. What is the ratio of the Educated labor force (% of total) in Turkey in 2001 to that in 2005?
Ensure brevity in your answer.  0.91. What is the ratio of the Educated labor force (% of total) of Cyprus in 2001 to that in 2006?
Offer a very short reply. 0.98. What is the ratio of the Educated labor force (% of total) in Macao in 2001 to that in 2006?
Provide a succinct answer. 0.72. What is the ratio of the Educated labor force (% of total) of New Zealand in 2001 to that in 2006?
Your answer should be very brief. 1.16. What is the ratio of the Educated labor force (% of total) of Turkey in 2001 to that in 2006?
Offer a terse response. 0.88. What is the ratio of the Educated labor force (% of total) of Cyprus in 2001 to that in 2007?
Give a very brief answer. 0.97. What is the ratio of the Educated labor force (% of total) in Macao in 2001 to that in 2007?
Keep it short and to the point. 0.7. What is the ratio of the Educated labor force (% of total) in New Zealand in 2001 to that in 2007?
Your response must be concise. 1.21. What is the ratio of the Educated labor force (% of total) in Turkey in 2001 to that in 2007?
Ensure brevity in your answer.  0.86. What is the ratio of the Educated labor force (% of total) in Cyprus in 2001 to that in 2008?
Your answer should be compact. 0.99. What is the ratio of the Educated labor force (% of total) in Macao in 2001 to that in 2008?
Offer a terse response. 0.62. What is the ratio of the Educated labor force (% of total) in New Zealand in 2001 to that in 2008?
Offer a very short reply. 1.2. What is the ratio of the Educated labor force (% of total) in Turkey in 2001 to that in 2008?
Give a very brief answer. 0.88. What is the ratio of the Educated labor force (% of total) of Cyprus in 2002 to that in 2005?
Your answer should be very brief. 0.96. What is the ratio of the Educated labor force (% of total) of Macao in 2002 to that in 2005?
Ensure brevity in your answer.  0.79. What is the ratio of the Educated labor force (% of total) of New Zealand in 2002 to that in 2005?
Offer a very short reply. 0.89. What is the ratio of the Educated labor force (% of total) in Turkey in 2002 to that in 2005?
Offer a very short reply. 0.96. What is the ratio of the Educated labor force (% of total) in Cyprus in 2002 to that in 2006?
Your response must be concise. 0.96. What is the ratio of the Educated labor force (% of total) in Macao in 2002 to that in 2006?
Provide a succinct answer. 0.75. What is the ratio of the Educated labor force (% of total) of New Zealand in 2002 to that in 2006?
Keep it short and to the point. 1.16. What is the ratio of the Educated labor force (% of total) in Turkey in 2002 to that in 2006?
Offer a very short reply. 0.92. What is the ratio of the Educated labor force (% of total) in Cyprus in 2002 to that in 2007?
Your response must be concise. 0.96. What is the ratio of the Educated labor force (% of total) of Macao in 2002 to that in 2007?
Make the answer very short. 0.72. What is the ratio of the Educated labor force (% of total) in New Zealand in 2002 to that in 2007?
Offer a terse response. 1.2. What is the ratio of the Educated labor force (% of total) in Turkey in 2002 to that in 2007?
Keep it short and to the point. 0.91. What is the ratio of the Educated labor force (% of total) of Cyprus in 2002 to that in 2008?
Keep it short and to the point. 0.97. What is the ratio of the Educated labor force (% of total) in Macao in 2002 to that in 2008?
Ensure brevity in your answer.  0.64. What is the ratio of the Educated labor force (% of total) of New Zealand in 2002 to that in 2008?
Ensure brevity in your answer.  1.2. What is the ratio of the Educated labor force (% of total) of Turkey in 2002 to that in 2008?
Offer a terse response. 0.93. What is the ratio of the Educated labor force (% of total) in Cyprus in 2005 to that in 2006?
Make the answer very short. 1. What is the ratio of the Educated labor force (% of total) in Macao in 2005 to that in 2006?
Make the answer very short. 0.94. What is the ratio of the Educated labor force (% of total) of New Zealand in 2005 to that in 2006?
Offer a terse response. 1.3. What is the ratio of the Educated labor force (% of total) of Turkey in 2005 to that in 2006?
Your answer should be very brief. 0.96. What is the ratio of the Educated labor force (% of total) in Macao in 2005 to that in 2007?
Offer a terse response. 0.91. What is the ratio of the Educated labor force (% of total) of New Zealand in 2005 to that in 2007?
Make the answer very short. 1.35. What is the ratio of the Educated labor force (% of total) of Turkey in 2005 to that in 2007?
Provide a succinct answer. 0.95. What is the ratio of the Educated labor force (% of total) of Macao in 2005 to that in 2008?
Your answer should be compact. 0.81. What is the ratio of the Educated labor force (% of total) of New Zealand in 2005 to that in 2008?
Provide a succinct answer. 1.34. What is the ratio of the Educated labor force (% of total) in Turkey in 2005 to that in 2008?
Your answer should be compact. 0.97. What is the ratio of the Educated labor force (% of total) of Macao in 2006 to that in 2007?
Your answer should be compact. 0.97. What is the ratio of the Educated labor force (% of total) in New Zealand in 2006 to that in 2007?
Your answer should be compact. 1.04. What is the ratio of the Educated labor force (% of total) in Turkey in 2006 to that in 2007?
Your response must be concise. 0.98. What is the ratio of the Educated labor force (% of total) in Cyprus in 2006 to that in 2008?
Ensure brevity in your answer.  1.01. What is the ratio of the Educated labor force (% of total) in Macao in 2006 to that in 2008?
Your answer should be very brief. 0.86. What is the ratio of the Educated labor force (% of total) in New Zealand in 2006 to that in 2008?
Offer a terse response. 1.03. What is the ratio of the Educated labor force (% of total) in Cyprus in 2007 to that in 2008?
Provide a short and direct response. 1.01. What is the ratio of the Educated labor force (% of total) in Macao in 2007 to that in 2008?
Your answer should be very brief. 0.89. What is the ratio of the Educated labor force (% of total) in Turkey in 2007 to that in 2008?
Ensure brevity in your answer.  1.02. What is the difference between the highest and the lowest Educated labor force (% of total) of Cyprus?
Provide a short and direct response. 1.8. 